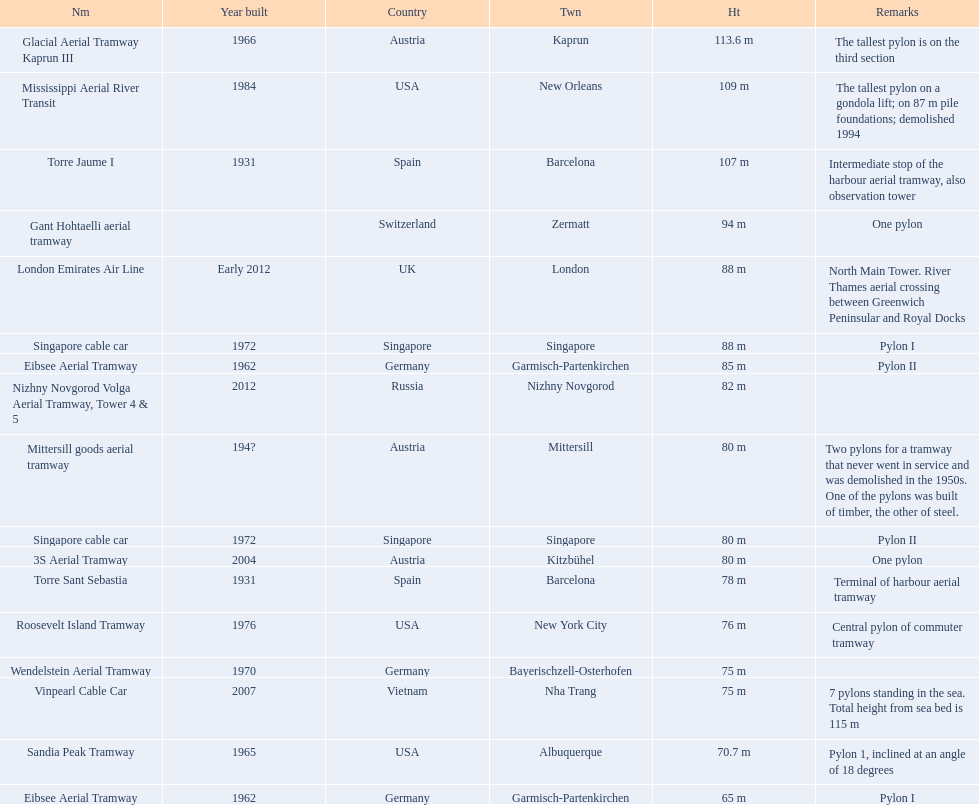Which lift has the second highest height? Mississippi Aerial River Transit. What is the value of the height? 109 m. 